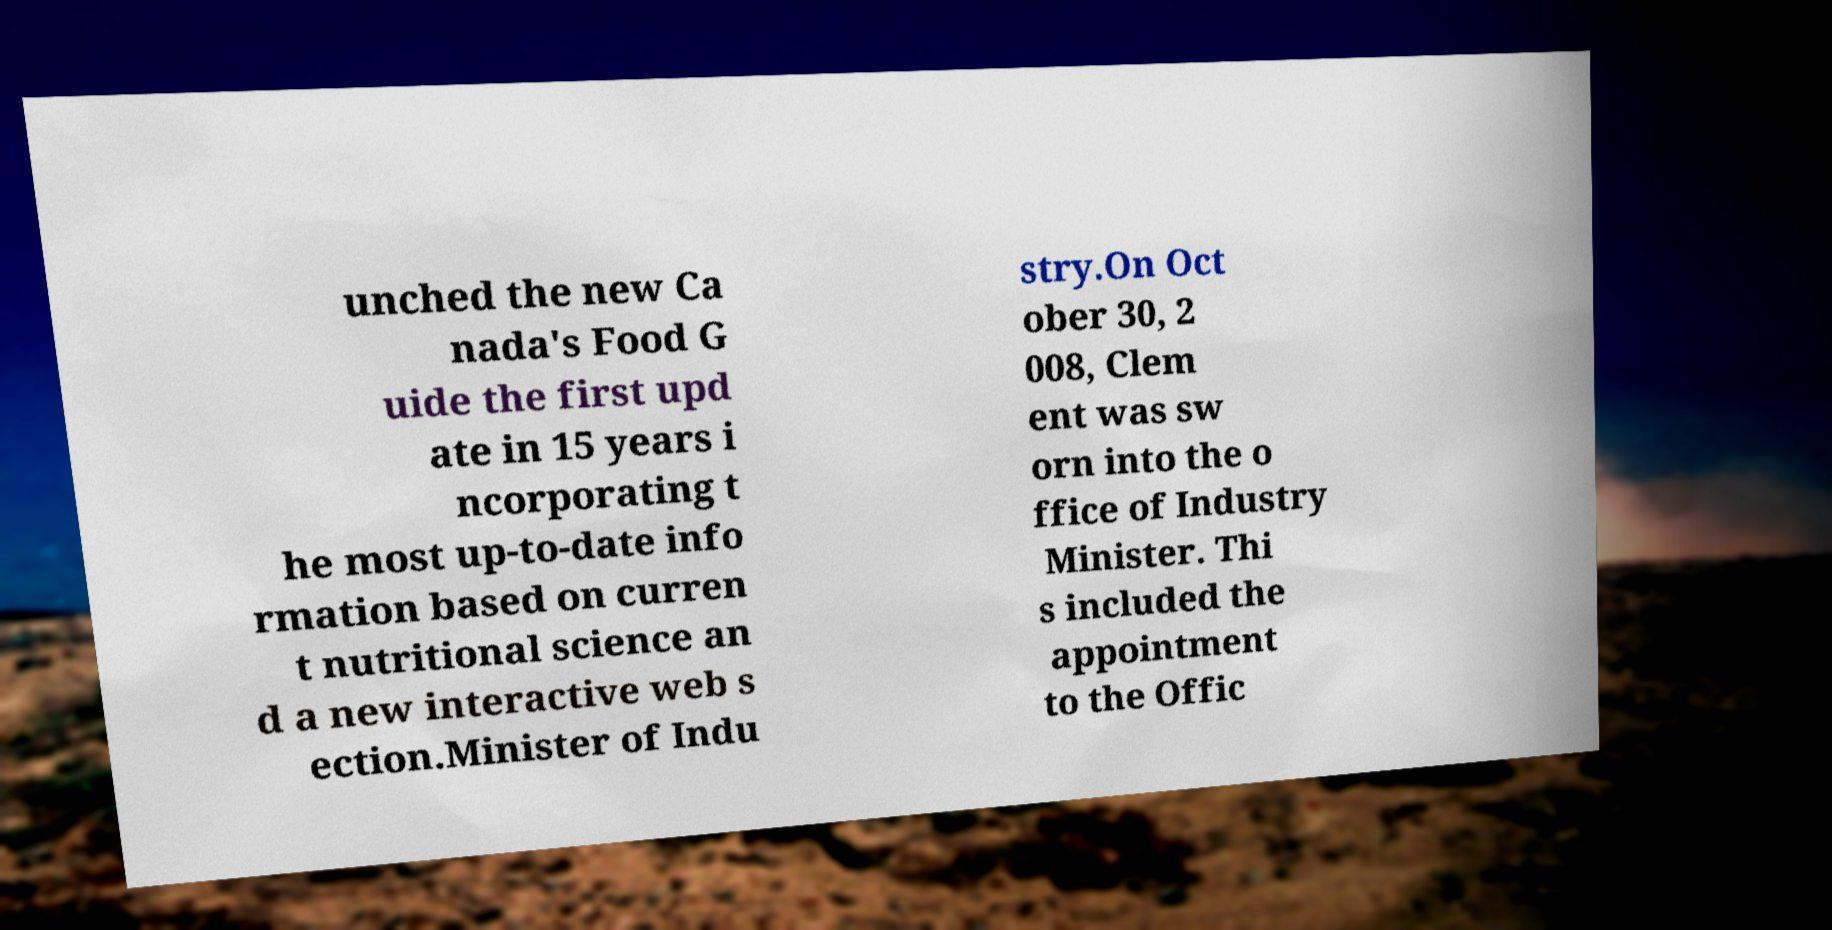What messages or text are displayed in this image? I need them in a readable, typed format. unched the new Ca nada's Food G uide the first upd ate in 15 years i ncorporating t he most up-to-date info rmation based on curren t nutritional science an d a new interactive web s ection.Minister of Indu stry.On Oct ober 30, 2 008, Clem ent was sw orn into the o ffice of Industry Minister. Thi s included the appointment to the Offic 